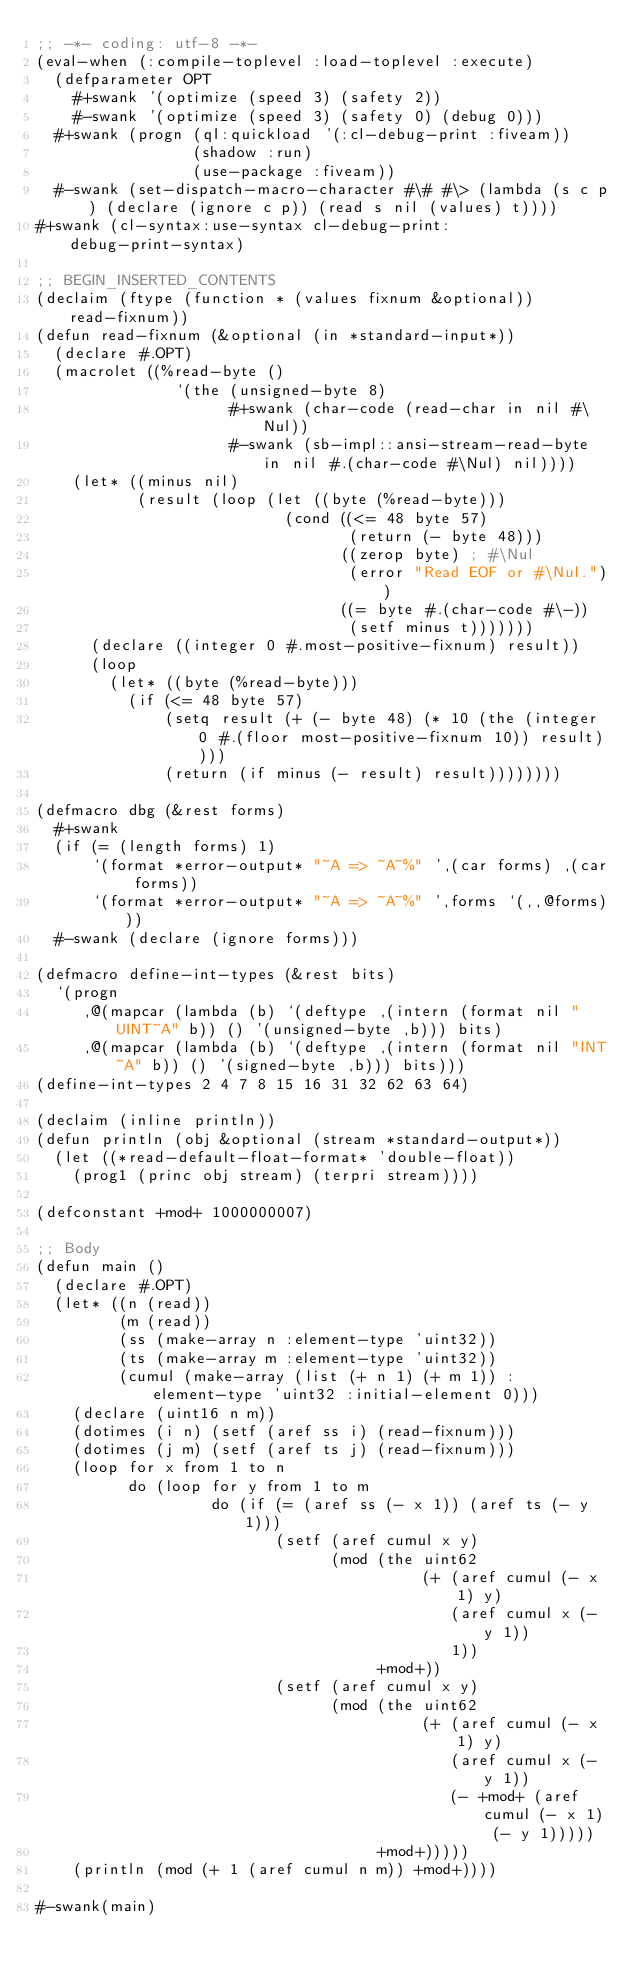Convert code to text. <code><loc_0><loc_0><loc_500><loc_500><_Lisp_>;; -*- coding: utf-8 -*-
(eval-when (:compile-toplevel :load-toplevel :execute)
  (defparameter OPT
    #+swank '(optimize (speed 3) (safety 2))
    #-swank '(optimize (speed 3) (safety 0) (debug 0)))
  #+swank (progn (ql:quickload '(:cl-debug-print :fiveam))
                 (shadow :run)
                 (use-package :fiveam))
  #-swank (set-dispatch-macro-character #\# #\> (lambda (s c p) (declare (ignore c p)) (read s nil (values) t))))
#+swank (cl-syntax:use-syntax cl-debug-print:debug-print-syntax)

;; BEGIN_INSERTED_CONTENTS
(declaim (ftype (function * (values fixnum &optional)) read-fixnum))
(defun read-fixnum (&optional (in *standard-input*))
  (declare #.OPT)
  (macrolet ((%read-byte ()
               `(the (unsigned-byte 8)
                     #+swank (char-code (read-char in nil #\Nul))
                     #-swank (sb-impl::ansi-stream-read-byte in nil #.(char-code #\Nul) nil))))
    (let* ((minus nil)
           (result (loop (let ((byte (%read-byte)))
                           (cond ((<= 48 byte 57)
                                  (return (- byte 48)))
                                 ((zerop byte) ; #\Nul
                                  (error "Read EOF or #\Nul."))
                                 ((= byte #.(char-code #\-))
                                  (setf minus t)))))))
      (declare ((integer 0 #.most-positive-fixnum) result))
      (loop
        (let* ((byte (%read-byte)))
          (if (<= 48 byte 57)
              (setq result (+ (- byte 48) (* 10 (the (integer 0 #.(floor most-positive-fixnum 10)) result))))
              (return (if minus (- result) result))))))))

(defmacro dbg (&rest forms)
  #+swank
  (if (= (length forms) 1)
      `(format *error-output* "~A => ~A~%" ',(car forms) ,(car forms))
      `(format *error-output* "~A => ~A~%" ',forms `(,,@forms)))
  #-swank (declare (ignore forms)))

(defmacro define-int-types (&rest bits)
  `(progn
     ,@(mapcar (lambda (b) `(deftype ,(intern (format nil "UINT~A" b)) () '(unsigned-byte ,b))) bits)
     ,@(mapcar (lambda (b) `(deftype ,(intern (format nil "INT~A" b)) () '(signed-byte ,b))) bits)))
(define-int-types 2 4 7 8 15 16 31 32 62 63 64)

(declaim (inline println))
(defun println (obj &optional (stream *standard-output*))
  (let ((*read-default-float-format* 'double-float))
    (prog1 (princ obj stream) (terpri stream))))

(defconstant +mod+ 1000000007)

;; Body
(defun main ()
  (declare #.OPT)
  (let* ((n (read))
         (m (read))
         (ss (make-array n :element-type 'uint32))
         (ts (make-array m :element-type 'uint32))
         (cumul (make-array (list (+ n 1) (+ m 1)) :element-type 'uint32 :initial-element 0)))
    (declare (uint16 n m))
    (dotimes (i n) (setf (aref ss i) (read-fixnum)))
    (dotimes (j m) (setf (aref ts j) (read-fixnum)))
    (loop for x from 1 to n
          do (loop for y from 1 to m
                   do (if (= (aref ss (- x 1)) (aref ts (- y 1)))
                          (setf (aref cumul x y)
                                (mod (the uint62
                                          (+ (aref cumul (- x 1) y)
                                             (aref cumul x (- y 1))
                                             1))
                                     +mod+))
                          (setf (aref cumul x y)
                                (mod (the uint62
                                          (+ (aref cumul (- x 1) y)
                                             (aref cumul x (- y 1))
                                             (- +mod+ (aref cumul (- x 1) (- y 1)))))
                                     +mod+)))))
    (println (mod (+ 1 (aref cumul n m)) +mod+))))

#-swank(main)
</code> 